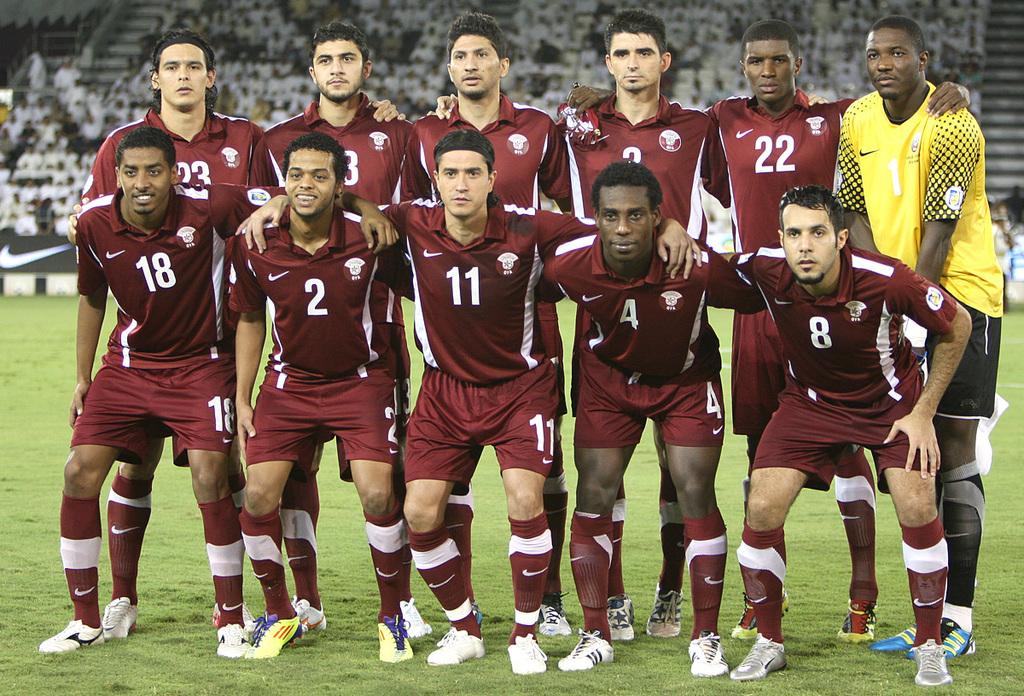What is the jersey of one of the players on the bottom row?
Keep it short and to the point. 11. What is the man infront of the man in yellows number?
Offer a terse response. 8. 